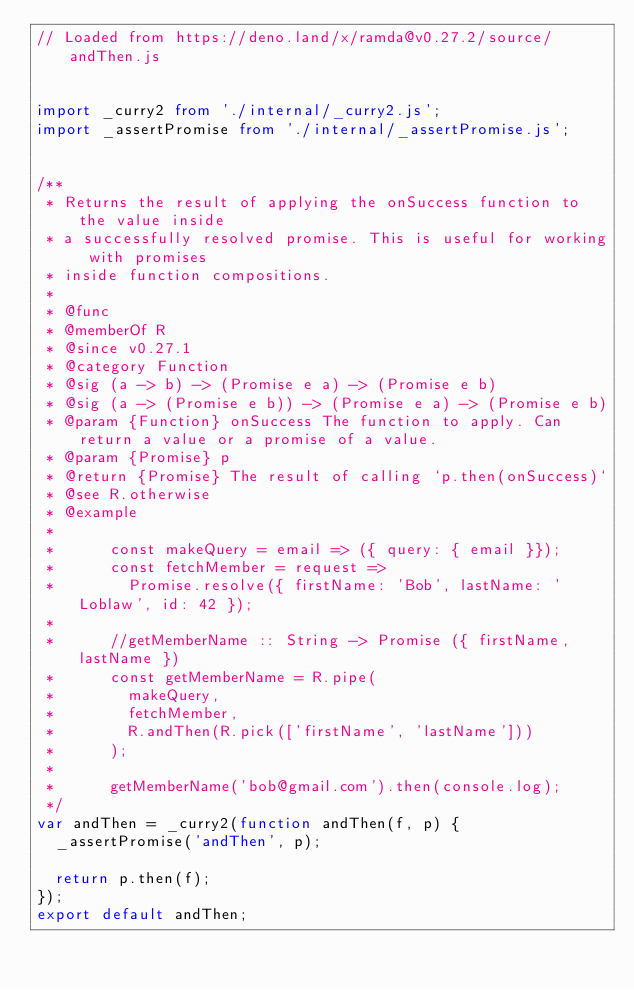<code> <loc_0><loc_0><loc_500><loc_500><_TypeScript_>// Loaded from https://deno.land/x/ramda@v0.27.2/source/andThen.js


import _curry2 from './internal/_curry2.js';
import _assertPromise from './internal/_assertPromise.js';


/**
 * Returns the result of applying the onSuccess function to the value inside
 * a successfully resolved promise. This is useful for working with promises
 * inside function compositions.
 *
 * @func
 * @memberOf R
 * @since v0.27.1
 * @category Function
 * @sig (a -> b) -> (Promise e a) -> (Promise e b)
 * @sig (a -> (Promise e b)) -> (Promise e a) -> (Promise e b)
 * @param {Function} onSuccess The function to apply. Can return a value or a promise of a value.
 * @param {Promise} p
 * @return {Promise} The result of calling `p.then(onSuccess)`
 * @see R.otherwise
 * @example
 *
 *      const makeQuery = email => ({ query: { email }});
 *      const fetchMember = request =>
 *        Promise.resolve({ firstName: 'Bob', lastName: 'Loblaw', id: 42 });
 *
 *      //getMemberName :: String -> Promise ({ firstName, lastName })
 *      const getMemberName = R.pipe(
 *        makeQuery,
 *        fetchMember,
 *        R.andThen(R.pick(['firstName', 'lastName']))
 *      );
 *
 *      getMemberName('bob@gmail.com').then(console.log);
 */
var andThen = _curry2(function andThen(f, p) {
  _assertPromise('andThen', p);

  return p.then(f);
});
export default andThen;
</code> 